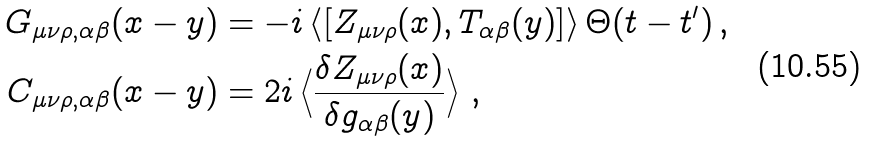Convert formula to latex. <formula><loc_0><loc_0><loc_500><loc_500>G _ { \mu \nu \rho , \alpha \beta } ( x - y ) & = - i \left \langle [ Z _ { \mu \nu \rho } ( x ) , T _ { \alpha \beta } ( y ) ] \right \rangle \Theta ( t - t ^ { \prime } ) \, , \\ C _ { \mu \nu \rho , \alpha \beta } ( x - y ) & = 2 i \left \langle \frac { \delta Z _ { \mu \nu \rho } ( x ) } { \delta g _ { \alpha \beta } ( y ) } \right \rangle \, ,</formula> 